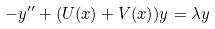Convert formula to latex. <formula><loc_0><loc_0><loc_500><loc_500>- y ^ { \prime \prime } + ( U ( x ) + V ( x ) ) y = \lambda y</formula> 